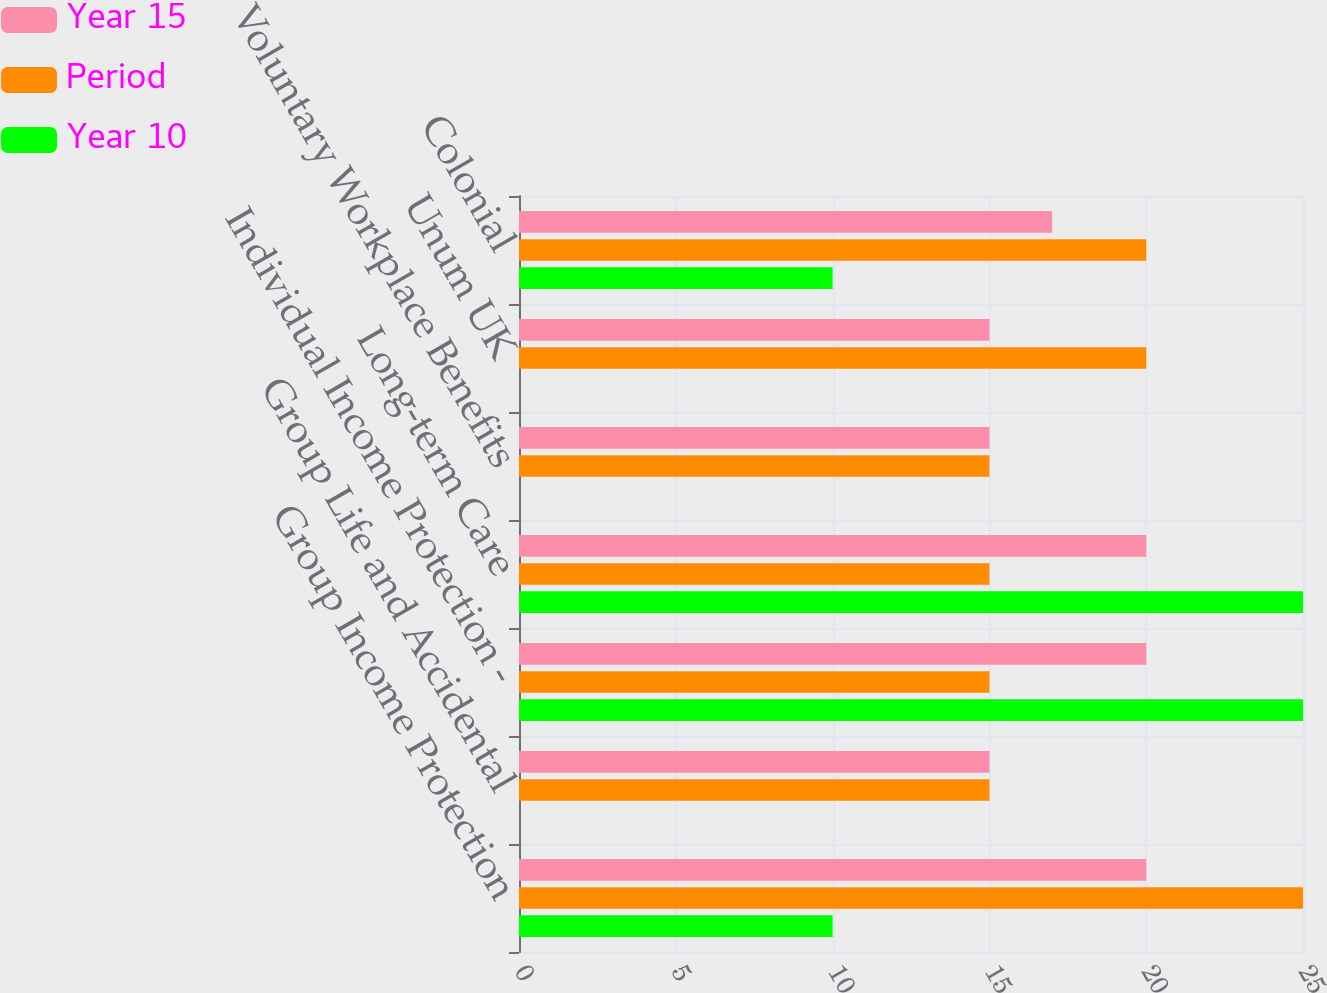<chart> <loc_0><loc_0><loc_500><loc_500><stacked_bar_chart><ecel><fcel>Group Income Protection<fcel>Group Life and Accidental<fcel>Individual Income Protection -<fcel>Long-term Care<fcel>Voluntary Workplace Benefits<fcel>Unum UK<fcel>Colonial<nl><fcel>Year 15<fcel>20<fcel>15<fcel>20<fcel>20<fcel>15<fcel>15<fcel>17<nl><fcel>Period<fcel>25<fcel>15<fcel>15<fcel>15<fcel>15<fcel>20<fcel>20<nl><fcel>Year 10<fcel>10<fcel>0<fcel>25<fcel>25<fcel>0<fcel>0<fcel>10<nl></chart> 